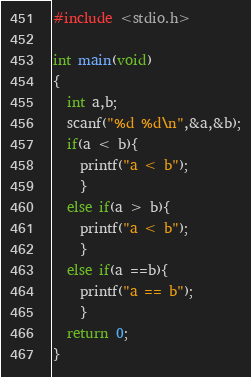Convert code to text. <code><loc_0><loc_0><loc_500><loc_500><_C_>#include <stdio.h>

int main(void)
{
  int a,b;
  scanf("%d %d\n",&a,&b);
  if(a < b){
    printf("a < b");
    }
  else if(a > b){
    printf("a < b");
    }
  else if(a ==b){
    printf("a == b");
    }
  return 0;
}</code> 